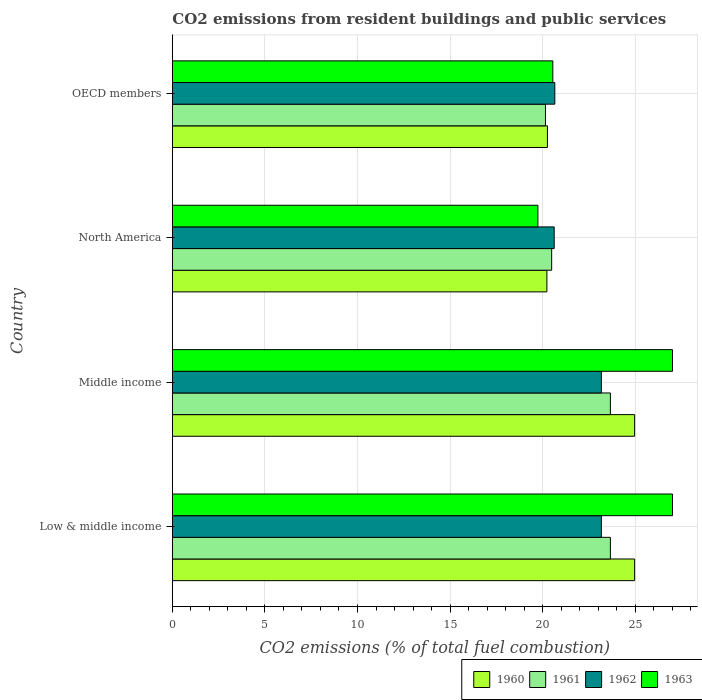How many groups of bars are there?
Ensure brevity in your answer.  4. Are the number of bars per tick equal to the number of legend labels?
Offer a very short reply. Yes. What is the label of the 3rd group of bars from the top?
Provide a short and direct response. Middle income. In how many cases, is the number of bars for a given country not equal to the number of legend labels?
Keep it short and to the point. 0. What is the total CO2 emitted in 1963 in Low & middle income?
Keep it short and to the point. 27.01. Across all countries, what is the maximum total CO2 emitted in 1963?
Provide a short and direct response. 27.01. Across all countries, what is the minimum total CO2 emitted in 1960?
Keep it short and to the point. 20.23. In which country was the total CO2 emitted in 1960 maximum?
Your answer should be compact. Low & middle income. What is the total total CO2 emitted in 1963 in the graph?
Your answer should be very brief. 94.33. What is the difference between the total CO2 emitted in 1961 in Middle income and that in OECD members?
Your response must be concise. 3.51. What is the difference between the total CO2 emitted in 1962 in OECD members and the total CO2 emitted in 1960 in Middle income?
Offer a very short reply. -4.31. What is the average total CO2 emitted in 1962 per country?
Give a very brief answer. 21.91. What is the difference between the total CO2 emitted in 1963 and total CO2 emitted in 1961 in Low & middle income?
Ensure brevity in your answer.  3.36. What is the ratio of the total CO2 emitted in 1963 in Low & middle income to that in OECD members?
Keep it short and to the point. 1.31. What is the difference between the highest and the second highest total CO2 emitted in 1962?
Provide a succinct answer. 0. What is the difference between the highest and the lowest total CO2 emitted in 1963?
Offer a very short reply. 7.27. Is the sum of the total CO2 emitted in 1960 in North America and OECD members greater than the maximum total CO2 emitted in 1961 across all countries?
Your answer should be compact. Yes. Is it the case that in every country, the sum of the total CO2 emitted in 1962 and total CO2 emitted in 1960 is greater than the sum of total CO2 emitted in 1961 and total CO2 emitted in 1963?
Provide a succinct answer. No. What does the 4th bar from the top in OECD members represents?
Ensure brevity in your answer.  1960. Is it the case that in every country, the sum of the total CO2 emitted in 1961 and total CO2 emitted in 1963 is greater than the total CO2 emitted in 1960?
Offer a terse response. Yes. Are all the bars in the graph horizontal?
Your response must be concise. Yes. How many countries are there in the graph?
Keep it short and to the point. 4. What is the difference between two consecutive major ticks on the X-axis?
Ensure brevity in your answer.  5. How many legend labels are there?
Ensure brevity in your answer.  4. How are the legend labels stacked?
Make the answer very short. Horizontal. What is the title of the graph?
Keep it short and to the point. CO2 emissions from resident buildings and public services. What is the label or title of the X-axis?
Provide a short and direct response. CO2 emissions (% of total fuel combustion). What is the CO2 emissions (% of total fuel combustion) in 1960 in Low & middle income?
Make the answer very short. 24.97. What is the CO2 emissions (% of total fuel combustion) of 1961 in Low & middle income?
Your answer should be compact. 23.66. What is the CO2 emissions (% of total fuel combustion) in 1962 in Low & middle income?
Offer a very short reply. 23.17. What is the CO2 emissions (% of total fuel combustion) of 1963 in Low & middle income?
Offer a terse response. 27.01. What is the CO2 emissions (% of total fuel combustion) in 1960 in Middle income?
Ensure brevity in your answer.  24.97. What is the CO2 emissions (% of total fuel combustion) in 1961 in Middle income?
Offer a very short reply. 23.66. What is the CO2 emissions (% of total fuel combustion) in 1962 in Middle income?
Your response must be concise. 23.17. What is the CO2 emissions (% of total fuel combustion) in 1963 in Middle income?
Offer a terse response. 27.01. What is the CO2 emissions (% of total fuel combustion) in 1960 in North America?
Offer a terse response. 20.23. What is the CO2 emissions (% of total fuel combustion) of 1961 in North America?
Make the answer very short. 20.49. What is the CO2 emissions (% of total fuel combustion) of 1962 in North America?
Your answer should be very brief. 20.62. What is the CO2 emissions (% of total fuel combustion) of 1963 in North America?
Make the answer very short. 19.74. What is the CO2 emissions (% of total fuel combustion) in 1960 in OECD members?
Provide a short and direct response. 20.26. What is the CO2 emissions (% of total fuel combustion) in 1961 in OECD members?
Offer a terse response. 20.15. What is the CO2 emissions (% of total fuel combustion) of 1962 in OECD members?
Offer a very short reply. 20.66. What is the CO2 emissions (% of total fuel combustion) of 1963 in OECD members?
Your answer should be very brief. 20.55. Across all countries, what is the maximum CO2 emissions (% of total fuel combustion) in 1960?
Give a very brief answer. 24.97. Across all countries, what is the maximum CO2 emissions (% of total fuel combustion) in 1961?
Ensure brevity in your answer.  23.66. Across all countries, what is the maximum CO2 emissions (% of total fuel combustion) of 1962?
Offer a terse response. 23.17. Across all countries, what is the maximum CO2 emissions (% of total fuel combustion) of 1963?
Provide a succinct answer. 27.01. Across all countries, what is the minimum CO2 emissions (% of total fuel combustion) in 1960?
Offer a terse response. 20.23. Across all countries, what is the minimum CO2 emissions (% of total fuel combustion) in 1961?
Your answer should be very brief. 20.15. Across all countries, what is the minimum CO2 emissions (% of total fuel combustion) in 1962?
Give a very brief answer. 20.62. Across all countries, what is the minimum CO2 emissions (% of total fuel combustion) of 1963?
Keep it short and to the point. 19.74. What is the total CO2 emissions (% of total fuel combustion) of 1960 in the graph?
Offer a very short reply. 90.43. What is the total CO2 emissions (% of total fuel combustion) of 1961 in the graph?
Your answer should be compact. 87.96. What is the total CO2 emissions (% of total fuel combustion) in 1962 in the graph?
Provide a succinct answer. 87.63. What is the total CO2 emissions (% of total fuel combustion) in 1963 in the graph?
Give a very brief answer. 94.33. What is the difference between the CO2 emissions (% of total fuel combustion) in 1962 in Low & middle income and that in Middle income?
Your response must be concise. 0. What is the difference between the CO2 emissions (% of total fuel combustion) in 1960 in Low & middle income and that in North America?
Your response must be concise. 4.74. What is the difference between the CO2 emissions (% of total fuel combustion) of 1961 in Low & middle income and that in North America?
Give a very brief answer. 3.17. What is the difference between the CO2 emissions (% of total fuel combustion) of 1962 in Low & middle income and that in North America?
Your answer should be very brief. 2.55. What is the difference between the CO2 emissions (% of total fuel combustion) of 1963 in Low & middle income and that in North America?
Provide a short and direct response. 7.27. What is the difference between the CO2 emissions (% of total fuel combustion) in 1960 in Low & middle income and that in OECD members?
Provide a short and direct response. 4.71. What is the difference between the CO2 emissions (% of total fuel combustion) in 1961 in Low & middle income and that in OECD members?
Make the answer very short. 3.51. What is the difference between the CO2 emissions (% of total fuel combustion) in 1962 in Low & middle income and that in OECD members?
Your answer should be very brief. 2.52. What is the difference between the CO2 emissions (% of total fuel combustion) in 1963 in Low & middle income and that in OECD members?
Your answer should be compact. 6.46. What is the difference between the CO2 emissions (% of total fuel combustion) in 1960 in Middle income and that in North America?
Your response must be concise. 4.74. What is the difference between the CO2 emissions (% of total fuel combustion) of 1961 in Middle income and that in North America?
Give a very brief answer. 3.17. What is the difference between the CO2 emissions (% of total fuel combustion) of 1962 in Middle income and that in North America?
Make the answer very short. 2.55. What is the difference between the CO2 emissions (% of total fuel combustion) of 1963 in Middle income and that in North America?
Ensure brevity in your answer.  7.27. What is the difference between the CO2 emissions (% of total fuel combustion) of 1960 in Middle income and that in OECD members?
Provide a short and direct response. 4.71. What is the difference between the CO2 emissions (% of total fuel combustion) in 1961 in Middle income and that in OECD members?
Offer a very short reply. 3.51. What is the difference between the CO2 emissions (% of total fuel combustion) in 1962 in Middle income and that in OECD members?
Give a very brief answer. 2.52. What is the difference between the CO2 emissions (% of total fuel combustion) of 1963 in Middle income and that in OECD members?
Your response must be concise. 6.46. What is the difference between the CO2 emissions (% of total fuel combustion) of 1960 in North America and that in OECD members?
Your answer should be compact. -0.03. What is the difference between the CO2 emissions (% of total fuel combustion) of 1961 in North America and that in OECD members?
Your answer should be very brief. 0.34. What is the difference between the CO2 emissions (% of total fuel combustion) of 1962 in North America and that in OECD members?
Ensure brevity in your answer.  -0.03. What is the difference between the CO2 emissions (% of total fuel combustion) in 1963 in North America and that in OECD members?
Your response must be concise. -0.81. What is the difference between the CO2 emissions (% of total fuel combustion) in 1960 in Low & middle income and the CO2 emissions (% of total fuel combustion) in 1961 in Middle income?
Your answer should be compact. 1.31. What is the difference between the CO2 emissions (% of total fuel combustion) of 1960 in Low & middle income and the CO2 emissions (% of total fuel combustion) of 1962 in Middle income?
Your response must be concise. 1.8. What is the difference between the CO2 emissions (% of total fuel combustion) in 1960 in Low & middle income and the CO2 emissions (% of total fuel combustion) in 1963 in Middle income?
Ensure brevity in your answer.  -2.05. What is the difference between the CO2 emissions (% of total fuel combustion) in 1961 in Low & middle income and the CO2 emissions (% of total fuel combustion) in 1962 in Middle income?
Provide a short and direct response. 0.49. What is the difference between the CO2 emissions (% of total fuel combustion) in 1961 in Low & middle income and the CO2 emissions (% of total fuel combustion) in 1963 in Middle income?
Your answer should be very brief. -3.35. What is the difference between the CO2 emissions (% of total fuel combustion) of 1962 in Low & middle income and the CO2 emissions (% of total fuel combustion) of 1963 in Middle income?
Ensure brevity in your answer.  -3.84. What is the difference between the CO2 emissions (% of total fuel combustion) of 1960 in Low & middle income and the CO2 emissions (% of total fuel combustion) of 1961 in North America?
Offer a very short reply. 4.48. What is the difference between the CO2 emissions (% of total fuel combustion) of 1960 in Low & middle income and the CO2 emissions (% of total fuel combustion) of 1962 in North America?
Offer a terse response. 4.35. What is the difference between the CO2 emissions (% of total fuel combustion) of 1960 in Low & middle income and the CO2 emissions (% of total fuel combustion) of 1963 in North America?
Your response must be concise. 5.22. What is the difference between the CO2 emissions (% of total fuel combustion) in 1961 in Low & middle income and the CO2 emissions (% of total fuel combustion) in 1962 in North America?
Provide a succinct answer. 3.04. What is the difference between the CO2 emissions (% of total fuel combustion) of 1961 in Low & middle income and the CO2 emissions (% of total fuel combustion) of 1963 in North America?
Ensure brevity in your answer.  3.92. What is the difference between the CO2 emissions (% of total fuel combustion) of 1962 in Low & middle income and the CO2 emissions (% of total fuel combustion) of 1963 in North America?
Offer a terse response. 3.43. What is the difference between the CO2 emissions (% of total fuel combustion) in 1960 in Low & middle income and the CO2 emissions (% of total fuel combustion) in 1961 in OECD members?
Provide a succinct answer. 4.82. What is the difference between the CO2 emissions (% of total fuel combustion) in 1960 in Low & middle income and the CO2 emissions (% of total fuel combustion) in 1962 in OECD members?
Make the answer very short. 4.31. What is the difference between the CO2 emissions (% of total fuel combustion) in 1960 in Low & middle income and the CO2 emissions (% of total fuel combustion) in 1963 in OECD members?
Offer a very short reply. 4.42. What is the difference between the CO2 emissions (% of total fuel combustion) in 1961 in Low & middle income and the CO2 emissions (% of total fuel combustion) in 1962 in OECD members?
Offer a terse response. 3. What is the difference between the CO2 emissions (% of total fuel combustion) in 1961 in Low & middle income and the CO2 emissions (% of total fuel combustion) in 1963 in OECD members?
Keep it short and to the point. 3.11. What is the difference between the CO2 emissions (% of total fuel combustion) of 1962 in Low & middle income and the CO2 emissions (% of total fuel combustion) of 1963 in OECD members?
Make the answer very short. 2.62. What is the difference between the CO2 emissions (% of total fuel combustion) in 1960 in Middle income and the CO2 emissions (% of total fuel combustion) in 1961 in North America?
Your response must be concise. 4.48. What is the difference between the CO2 emissions (% of total fuel combustion) in 1960 in Middle income and the CO2 emissions (% of total fuel combustion) in 1962 in North America?
Offer a very short reply. 4.35. What is the difference between the CO2 emissions (% of total fuel combustion) in 1960 in Middle income and the CO2 emissions (% of total fuel combustion) in 1963 in North America?
Give a very brief answer. 5.22. What is the difference between the CO2 emissions (% of total fuel combustion) of 1961 in Middle income and the CO2 emissions (% of total fuel combustion) of 1962 in North America?
Make the answer very short. 3.04. What is the difference between the CO2 emissions (% of total fuel combustion) of 1961 in Middle income and the CO2 emissions (% of total fuel combustion) of 1963 in North America?
Make the answer very short. 3.92. What is the difference between the CO2 emissions (% of total fuel combustion) in 1962 in Middle income and the CO2 emissions (% of total fuel combustion) in 1963 in North America?
Provide a succinct answer. 3.43. What is the difference between the CO2 emissions (% of total fuel combustion) of 1960 in Middle income and the CO2 emissions (% of total fuel combustion) of 1961 in OECD members?
Keep it short and to the point. 4.82. What is the difference between the CO2 emissions (% of total fuel combustion) in 1960 in Middle income and the CO2 emissions (% of total fuel combustion) in 1962 in OECD members?
Offer a terse response. 4.31. What is the difference between the CO2 emissions (% of total fuel combustion) in 1960 in Middle income and the CO2 emissions (% of total fuel combustion) in 1963 in OECD members?
Keep it short and to the point. 4.42. What is the difference between the CO2 emissions (% of total fuel combustion) of 1961 in Middle income and the CO2 emissions (% of total fuel combustion) of 1962 in OECD members?
Give a very brief answer. 3. What is the difference between the CO2 emissions (% of total fuel combustion) of 1961 in Middle income and the CO2 emissions (% of total fuel combustion) of 1963 in OECD members?
Ensure brevity in your answer.  3.11. What is the difference between the CO2 emissions (% of total fuel combustion) of 1962 in Middle income and the CO2 emissions (% of total fuel combustion) of 1963 in OECD members?
Your answer should be compact. 2.62. What is the difference between the CO2 emissions (% of total fuel combustion) of 1960 in North America and the CO2 emissions (% of total fuel combustion) of 1961 in OECD members?
Your answer should be very brief. 0.08. What is the difference between the CO2 emissions (% of total fuel combustion) of 1960 in North America and the CO2 emissions (% of total fuel combustion) of 1962 in OECD members?
Provide a short and direct response. -0.43. What is the difference between the CO2 emissions (% of total fuel combustion) of 1960 in North America and the CO2 emissions (% of total fuel combustion) of 1963 in OECD members?
Ensure brevity in your answer.  -0.32. What is the difference between the CO2 emissions (% of total fuel combustion) of 1961 in North America and the CO2 emissions (% of total fuel combustion) of 1962 in OECD members?
Provide a short and direct response. -0.17. What is the difference between the CO2 emissions (% of total fuel combustion) of 1961 in North America and the CO2 emissions (% of total fuel combustion) of 1963 in OECD members?
Your answer should be very brief. -0.06. What is the difference between the CO2 emissions (% of total fuel combustion) of 1962 in North America and the CO2 emissions (% of total fuel combustion) of 1963 in OECD members?
Your answer should be compact. 0.07. What is the average CO2 emissions (% of total fuel combustion) of 1960 per country?
Offer a very short reply. 22.61. What is the average CO2 emissions (% of total fuel combustion) in 1961 per country?
Provide a succinct answer. 21.99. What is the average CO2 emissions (% of total fuel combustion) in 1962 per country?
Your answer should be compact. 21.91. What is the average CO2 emissions (% of total fuel combustion) in 1963 per country?
Your answer should be compact. 23.58. What is the difference between the CO2 emissions (% of total fuel combustion) in 1960 and CO2 emissions (% of total fuel combustion) in 1961 in Low & middle income?
Your answer should be compact. 1.31. What is the difference between the CO2 emissions (% of total fuel combustion) in 1960 and CO2 emissions (% of total fuel combustion) in 1962 in Low & middle income?
Offer a terse response. 1.8. What is the difference between the CO2 emissions (% of total fuel combustion) in 1960 and CO2 emissions (% of total fuel combustion) in 1963 in Low & middle income?
Your response must be concise. -2.05. What is the difference between the CO2 emissions (% of total fuel combustion) of 1961 and CO2 emissions (% of total fuel combustion) of 1962 in Low & middle income?
Offer a terse response. 0.49. What is the difference between the CO2 emissions (% of total fuel combustion) in 1961 and CO2 emissions (% of total fuel combustion) in 1963 in Low & middle income?
Keep it short and to the point. -3.35. What is the difference between the CO2 emissions (% of total fuel combustion) in 1962 and CO2 emissions (% of total fuel combustion) in 1963 in Low & middle income?
Give a very brief answer. -3.84. What is the difference between the CO2 emissions (% of total fuel combustion) of 1960 and CO2 emissions (% of total fuel combustion) of 1961 in Middle income?
Your answer should be very brief. 1.31. What is the difference between the CO2 emissions (% of total fuel combustion) of 1960 and CO2 emissions (% of total fuel combustion) of 1962 in Middle income?
Make the answer very short. 1.8. What is the difference between the CO2 emissions (% of total fuel combustion) of 1960 and CO2 emissions (% of total fuel combustion) of 1963 in Middle income?
Offer a terse response. -2.05. What is the difference between the CO2 emissions (% of total fuel combustion) in 1961 and CO2 emissions (% of total fuel combustion) in 1962 in Middle income?
Offer a terse response. 0.49. What is the difference between the CO2 emissions (% of total fuel combustion) of 1961 and CO2 emissions (% of total fuel combustion) of 1963 in Middle income?
Your answer should be very brief. -3.35. What is the difference between the CO2 emissions (% of total fuel combustion) of 1962 and CO2 emissions (% of total fuel combustion) of 1963 in Middle income?
Ensure brevity in your answer.  -3.84. What is the difference between the CO2 emissions (% of total fuel combustion) in 1960 and CO2 emissions (% of total fuel combustion) in 1961 in North America?
Keep it short and to the point. -0.26. What is the difference between the CO2 emissions (% of total fuel combustion) in 1960 and CO2 emissions (% of total fuel combustion) in 1962 in North America?
Provide a short and direct response. -0.39. What is the difference between the CO2 emissions (% of total fuel combustion) of 1960 and CO2 emissions (% of total fuel combustion) of 1963 in North America?
Give a very brief answer. 0.49. What is the difference between the CO2 emissions (% of total fuel combustion) in 1961 and CO2 emissions (% of total fuel combustion) in 1962 in North America?
Your answer should be very brief. -0.14. What is the difference between the CO2 emissions (% of total fuel combustion) in 1961 and CO2 emissions (% of total fuel combustion) in 1963 in North America?
Give a very brief answer. 0.74. What is the difference between the CO2 emissions (% of total fuel combustion) in 1962 and CO2 emissions (% of total fuel combustion) in 1963 in North America?
Give a very brief answer. 0.88. What is the difference between the CO2 emissions (% of total fuel combustion) of 1960 and CO2 emissions (% of total fuel combustion) of 1961 in OECD members?
Provide a succinct answer. 0.11. What is the difference between the CO2 emissions (% of total fuel combustion) of 1960 and CO2 emissions (% of total fuel combustion) of 1962 in OECD members?
Provide a succinct answer. -0.4. What is the difference between the CO2 emissions (% of total fuel combustion) in 1960 and CO2 emissions (% of total fuel combustion) in 1963 in OECD members?
Make the answer very short. -0.29. What is the difference between the CO2 emissions (% of total fuel combustion) of 1961 and CO2 emissions (% of total fuel combustion) of 1962 in OECD members?
Provide a succinct answer. -0.5. What is the difference between the CO2 emissions (% of total fuel combustion) in 1961 and CO2 emissions (% of total fuel combustion) in 1963 in OECD members?
Provide a short and direct response. -0.4. What is the difference between the CO2 emissions (% of total fuel combustion) of 1962 and CO2 emissions (% of total fuel combustion) of 1963 in OECD members?
Ensure brevity in your answer.  0.11. What is the ratio of the CO2 emissions (% of total fuel combustion) of 1960 in Low & middle income to that in Middle income?
Ensure brevity in your answer.  1. What is the ratio of the CO2 emissions (% of total fuel combustion) of 1963 in Low & middle income to that in Middle income?
Your response must be concise. 1. What is the ratio of the CO2 emissions (% of total fuel combustion) in 1960 in Low & middle income to that in North America?
Ensure brevity in your answer.  1.23. What is the ratio of the CO2 emissions (% of total fuel combustion) in 1961 in Low & middle income to that in North America?
Provide a short and direct response. 1.15. What is the ratio of the CO2 emissions (% of total fuel combustion) of 1962 in Low & middle income to that in North America?
Your answer should be compact. 1.12. What is the ratio of the CO2 emissions (% of total fuel combustion) of 1963 in Low & middle income to that in North America?
Give a very brief answer. 1.37. What is the ratio of the CO2 emissions (% of total fuel combustion) of 1960 in Low & middle income to that in OECD members?
Offer a very short reply. 1.23. What is the ratio of the CO2 emissions (% of total fuel combustion) in 1961 in Low & middle income to that in OECD members?
Offer a terse response. 1.17. What is the ratio of the CO2 emissions (% of total fuel combustion) of 1962 in Low & middle income to that in OECD members?
Give a very brief answer. 1.12. What is the ratio of the CO2 emissions (% of total fuel combustion) of 1963 in Low & middle income to that in OECD members?
Offer a terse response. 1.31. What is the ratio of the CO2 emissions (% of total fuel combustion) of 1960 in Middle income to that in North America?
Give a very brief answer. 1.23. What is the ratio of the CO2 emissions (% of total fuel combustion) in 1961 in Middle income to that in North America?
Provide a short and direct response. 1.15. What is the ratio of the CO2 emissions (% of total fuel combustion) in 1962 in Middle income to that in North America?
Provide a succinct answer. 1.12. What is the ratio of the CO2 emissions (% of total fuel combustion) of 1963 in Middle income to that in North America?
Your answer should be very brief. 1.37. What is the ratio of the CO2 emissions (% of total fuel combustion) of 1960 in Middle income to that in OECD members?
Provide a short and direct response. 1.23. What is the ratio of the CO2 emissions (% of total fuel combustion) of 1961 in Middle income to that in OECD members?
Offer a terse response. 1.17. What is the ratio of the CO2 emissions (% of total fuel combustion) in 1962 in Middle income to that in OECD members?
Offer a very short reply. 1.12. What is the ratio of the CO2 emissions (% of total fuel combustion) in 1963 in Middle income to that in OECD members?
Your response must be concise. 1.31. What is the ratio of the CO2 emissions (% of total fuel combustion) in 1961 in North America to that in OECD members?
Offer a terse response. 1.02. What is the ratio of the CO2 emissions (% of total fuel combustion) of 1963 in North America to that in OECD members?
Offer a terse response. 0.96. What is the difference between the highest and the second highest CO2 emissions (% of total fuel combustion) of 1960?
Your answer should be very brief. 0. What is the difference between the highest and the second highest CO2 emissions (% of total fuel combustion) of 1961?
Provide a short and direct response. 0. What is the difference between the highest and the second highest CO2 emissions (% of total fuel combustion) in 1962?
Ensure brevity in your answer.  0. What is the difference between the highest and the second highest CO2 emissions (% of total fuel combustion) in 1963?
Your response must be concise. 0. What is the difference between the highest and the lowest CO2 emissions (% of total fuel combustion) of 1960?
Offer a very short reply. 4.74. What is the difference between the highest and the lowest CO2 emissions (% of total fuel combustion) in 1961?
Give a very brief answer. 3.51. What is the difference between the highest and the lowest CO2 emissions (% of total fuel combustion) of 1962?
Ensure brevity in your answer.  2.55. What is the difference between the highest and the lowest CO2 emissions (% of total fuel combustion) in 1963?
Your answer should be very brief. 7.27. 